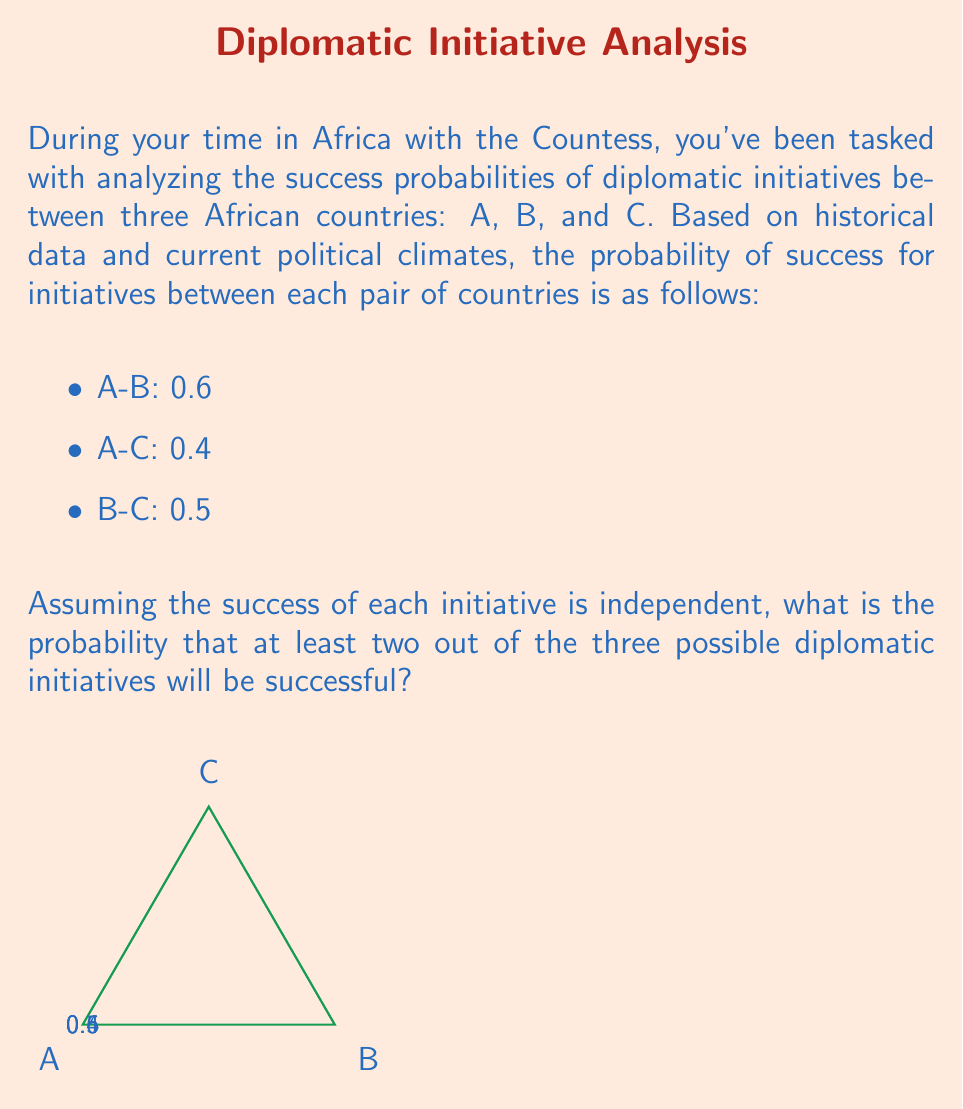Give your solution to this math problem. Let's approach this step-by-step using probability theory:

1) First, let's define our events:
   Let $X$ = success of A-B initiative
   Let $Y$ = success of A-C initiative
   Let $Z$ = success of B-C initiative

2) We're looking for the probability of at least two successes. It's easier to calculate this by subtracting the probability of zero or one success from 1.

3) Probability of zero successes:
   $P(\text{no success}) = (1-0.6)(1-0.4)(1-0.5) = 0.4 \cdot 0.6 \cdot 0.5 = 0.12$

4) Probability of exactly one success:
   $P(X\text{ only}) = 0.6 \cdot 0.6 \cdot 0.5 = 0.18$
   $P(Y\text{ only}) = 0.4 \cdot 0.4 \cdot 0.5 = 0.08$
   $P(Z\text{ only}) = 0.5 \cdot 0.6 \cdot 0.4 = 0.12$
   
   $P(\text{exactly one success}) = 0.18 + 0.08 + 0.12 = 0.38$

5) Therefore, the probability of at least two successes is:
   $P(\text{at least two successes}) = 1 - P(\text{no success}) - P(\text{exactly one success})$
   $= 1 - 0.12 - 0.38 = 0.50$

Thus, there is a 50% chance that at least two out of the three diplomatic initiatives will be successful.
Answer: 0.50 